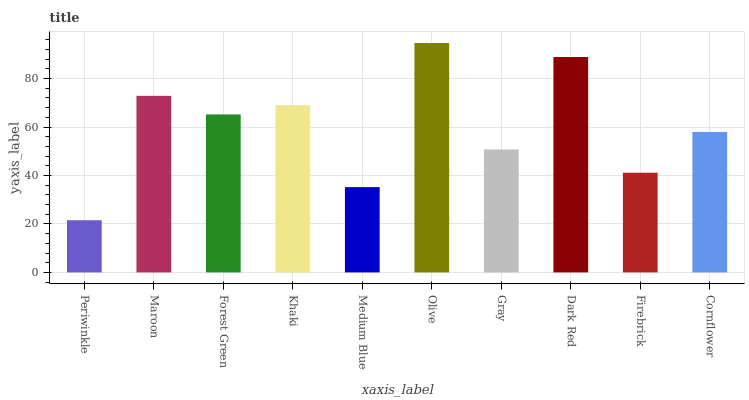Is Periwinkle the minimum?
Answer yes or no. Yes. Is Olive the maximum?
Answer yes or no. Yes. Is Maroon the minimum?
Answer yes or no. No. Is Maroon the maximum?
Answer yes or no. No. Is Maroon greater than Periwinkle?
Answer yes or no. Yes. Is Periwinkle less than Maroon?
Answer yes or no. Yes. Is Periwinkle greater than Maroon?
Answer yes or no. No. Is Maroon less than Periwinkle?
Answer yes or no. No. Is Forest Green the high median?
Answer yes or no. Yes. Is Cornflower the low median?
Answer yes or no. Yes. Is Firebrick the high median?
Answer yes or no. No. Is Firebrick the low median?
Answer yes or no. No. 